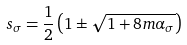<formula> <loc_0><loc_0><loc_500><loc_500>s _ { \sigma } = \frac { 1 } { 2 } \left ( 1 \pm \sqrt { 1 + 8 m \alpha _ { \sigma } } \right )</formula> 